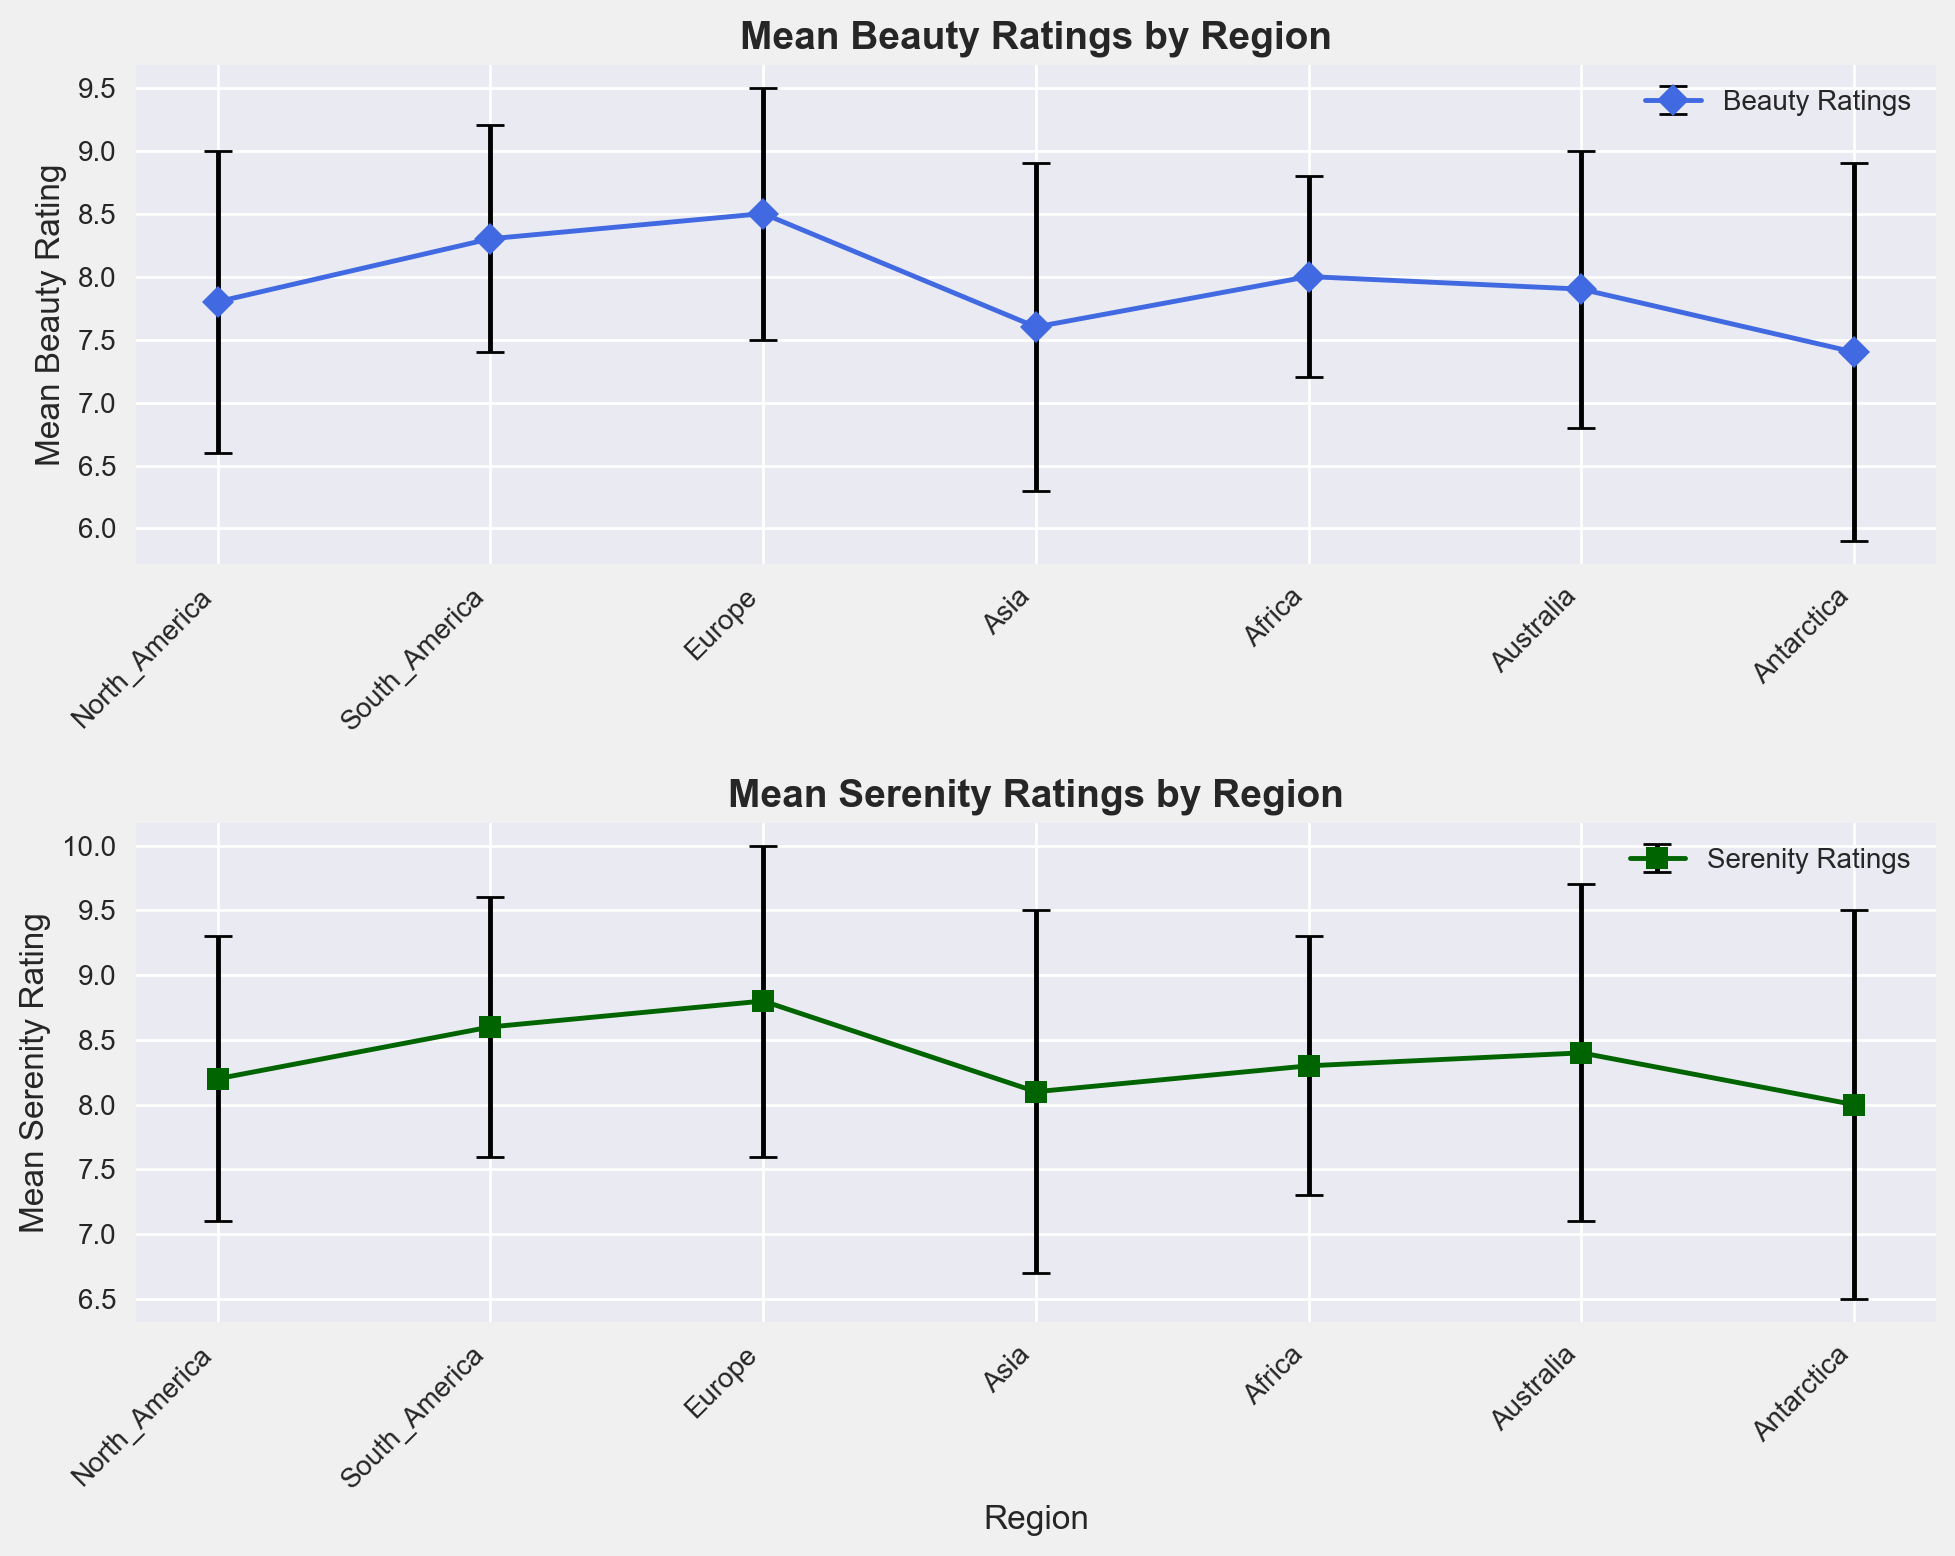Which region has the highest mean beauty rating? The plot shows that Europe has the highest mean beauty rating compared to other regions.
Answer: Europe What is the difference between the mean beauty rating of Asia and Antarctica? Subtract the mean beauty rating of Antarctica (7.4) from the mean beauty rating of Asia (7.6).
Answer: 0.2 Which region has the largest spread (standard deviation) in serenity ratings? The plot shows that Antarctica has the largest standard deviation in serenity ratings, represented by longer error bars.
Answer: Antarctica Are the mean beauty and serenity ratings the same for any region? By comparing both plots for similarities, it's clear they are not the same for any region, as all mean ratings differ in value.
Answer: No Which region has a higher mean serenity rating, Africa or Australia? Compare mean serenity ratings of Africa (8.3) and Australia (8.4); Australia has a slightly higher rating.
Answer: Australia What can be inferred about the viewers' perceived beauty and serenity of landscape photographs from Europe? Europe has the highest ratings for both beauty (8.5) and serenity (8.8), suggesting that viewers find landscape photographs from Europe highly beautiful and serene.
Answer: High beauty and serenity Calculate the average mean beauty rating across all regions. Sum all mean beauty ratings: 7.8 + 8.3 + 8.5 + 7.6 + 8.0 + 7.9 + 7.4 = 55.5. Divide by the number of regions (7): 55.5 / 7 = 7.93.
Answer: 7.93 Is the mean serenity rating for South America above or below the global average? Calculate the average mean serenity rating: (8.2 + 8.6 + 8.8 + 8.1 + 8.3 + 8.4 + 8.0) / 7 = 8.2. Compare it with South America's serenity rating (8.6). South America's rating is above the average.
Answer: Above Which region has the lowest mean beauty rating, and what does this suggest about viewers' perceptions? The plot shows that Antarctica has the lowest mean beauty rating (7.4), suggesting that viewers perceive landscape photographs from Antarctica as less beautiful compared to other regions.
Answer: Antarctica How do the error bars for beauty ratings in North America compare to those in Asia? Compare the length of the error bars in North America's beauty ratings plot (shorter) to those in Asia's plot (longer). This indicates less variation in viewer responses in North America compared to Asia.
Answer: Less variation 